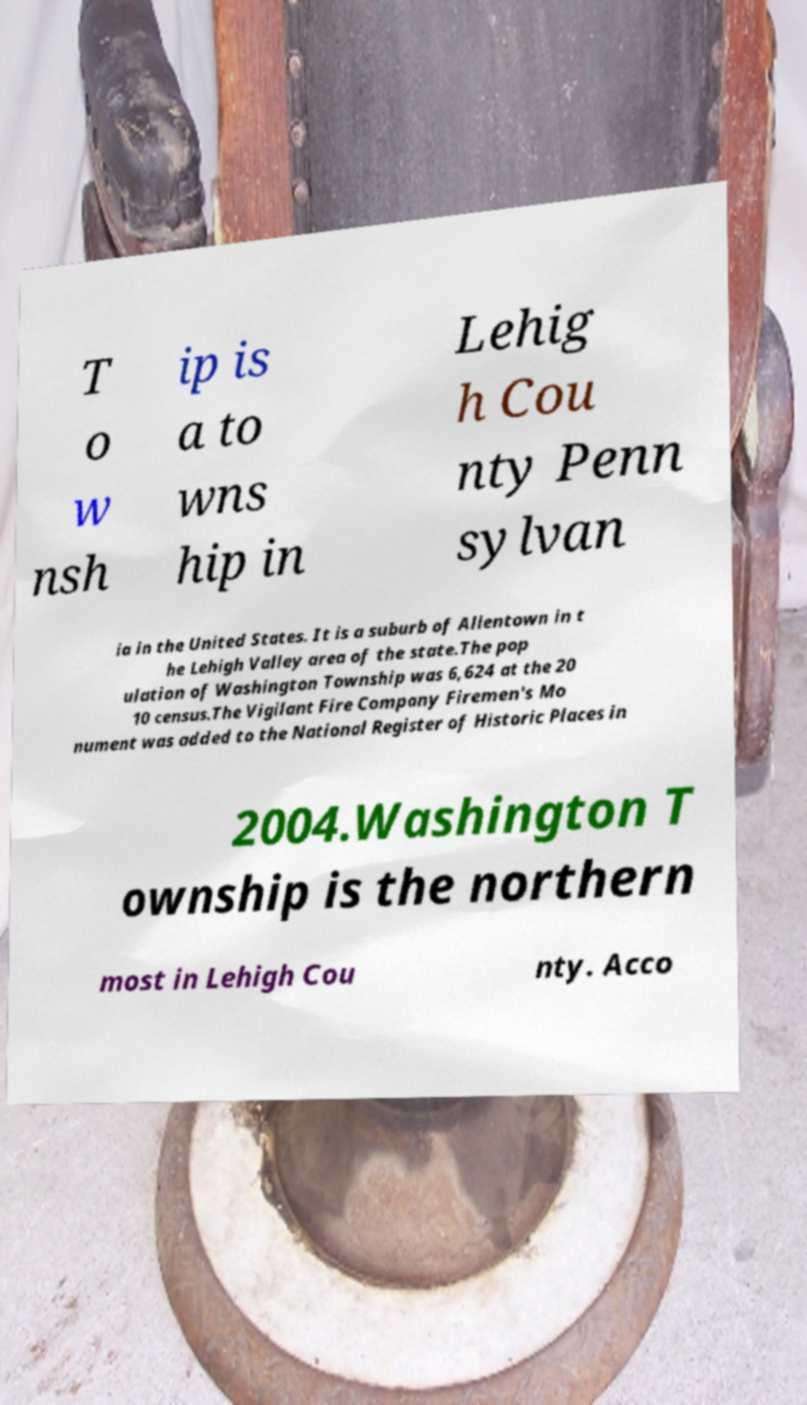Please read and relay the text visible in this image. What does it say? T o w nsh ip is a to wns hip in Lehig h Cou nty Penn sylvan ia in the United States. It is a suburb of Allentown in t he Lehigh Valley area of the state.The pop ulation of Washington Township was 6,624 at the 20 10 census.The Vigilant Fire Company Firemen's Mo nument was added to the National Register of Historic Places in 2004.Washington T ownship is the northern most in Lehigh Cou nty. Acco 